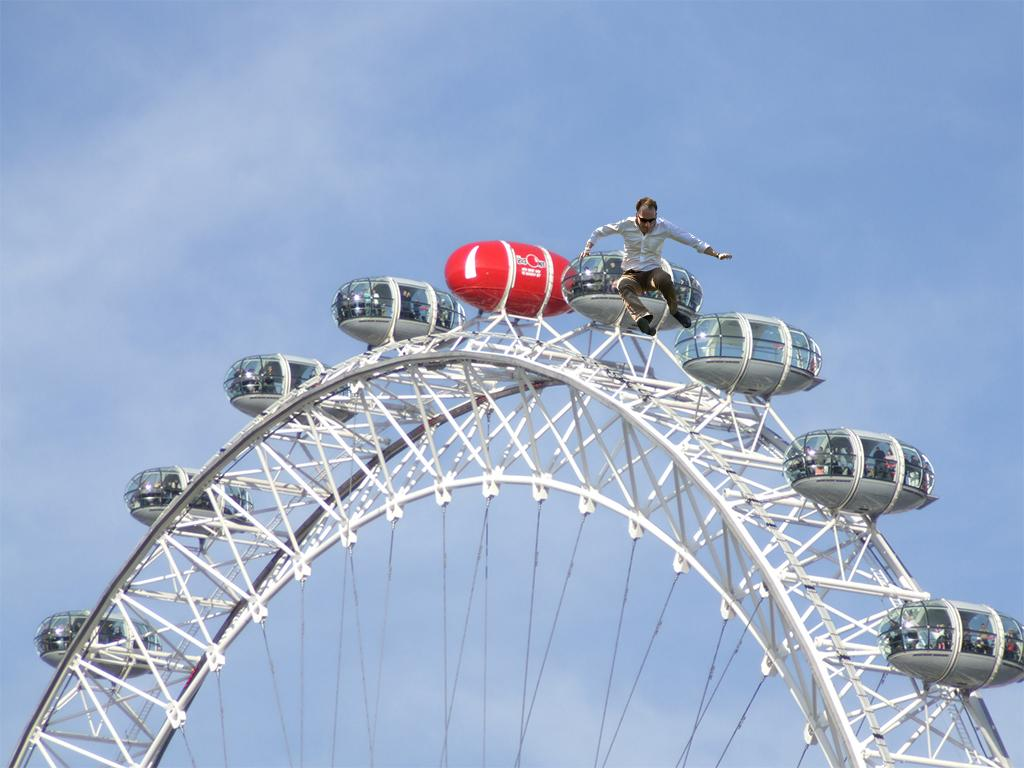Where was the image taken? The image was taken outdoors. What can be seen in the background of the image? There is the sky with clouds in the background. What is the main subject in the middle of the image? There is a Ferris wheel in the middle of the image. Can you describe the person in the image? There is a man on the Ferris wheel. What is the crook's desire in the image? There is no crook or any indication of a desire in the image; it features a Ferris wheel and a man. What decision does the man make while on the Ferris wheel? The image does not show the man making any decisions; he is simply riding the Ferris wheel. 